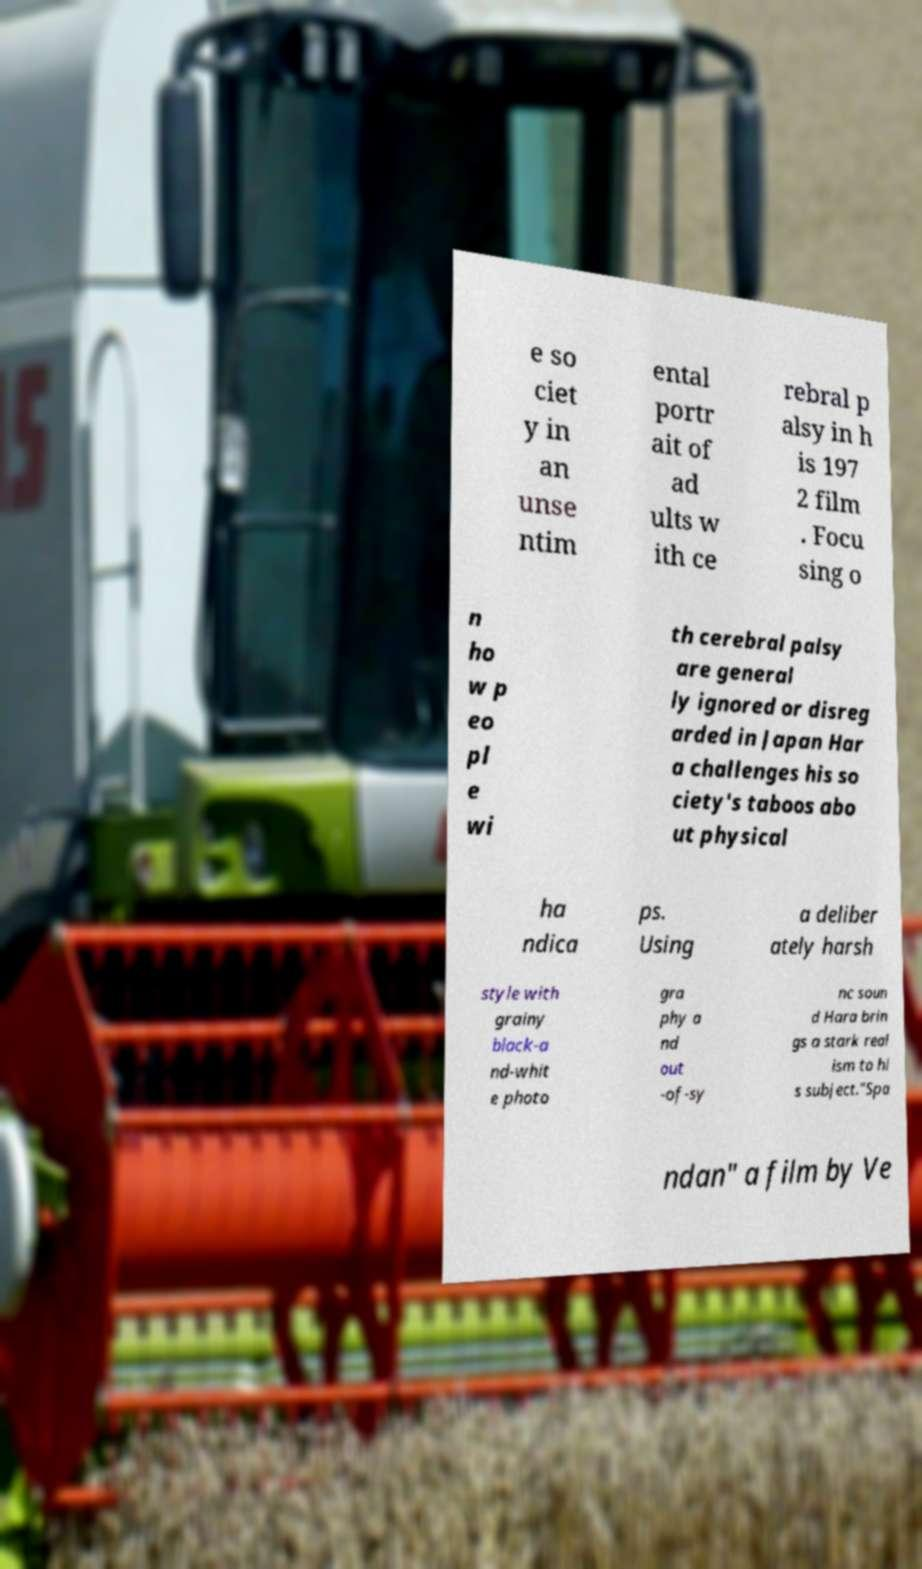Can you read and provide the text displayed in the image?This photo seems to have some interesting text. Can you extract and type it out for me? e so ciet y in an unse ntim ental portr ait of ad ults w ith ce rebral p alsy in h is 197 2 film . Focu sing o n ho w p eo pl e wi th cerebral palsy are general ly ignored or disreg arded in Japan Har a challenges his so ciety's taboos abo ut physical ha ndica ps. Using a deliber ately harsh style with grainy black-a nd-whit e photo gra phy a nd out -of-sy nc soun d Hara brin gs a stark real ism to hi s subject."Spa ndan" a film by Ve 